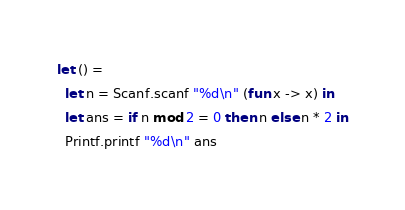Convert code to text. <code><loc_0><loc_0><loc_500><loc_500><_OCaml_>let () =
  let n = Scanf.scanf "%d\n" (fun x -> x) in
  let ans = if n mod 2 = 0 then n else n * 2 in
  Printf.printf "%d\n" ans</code> 